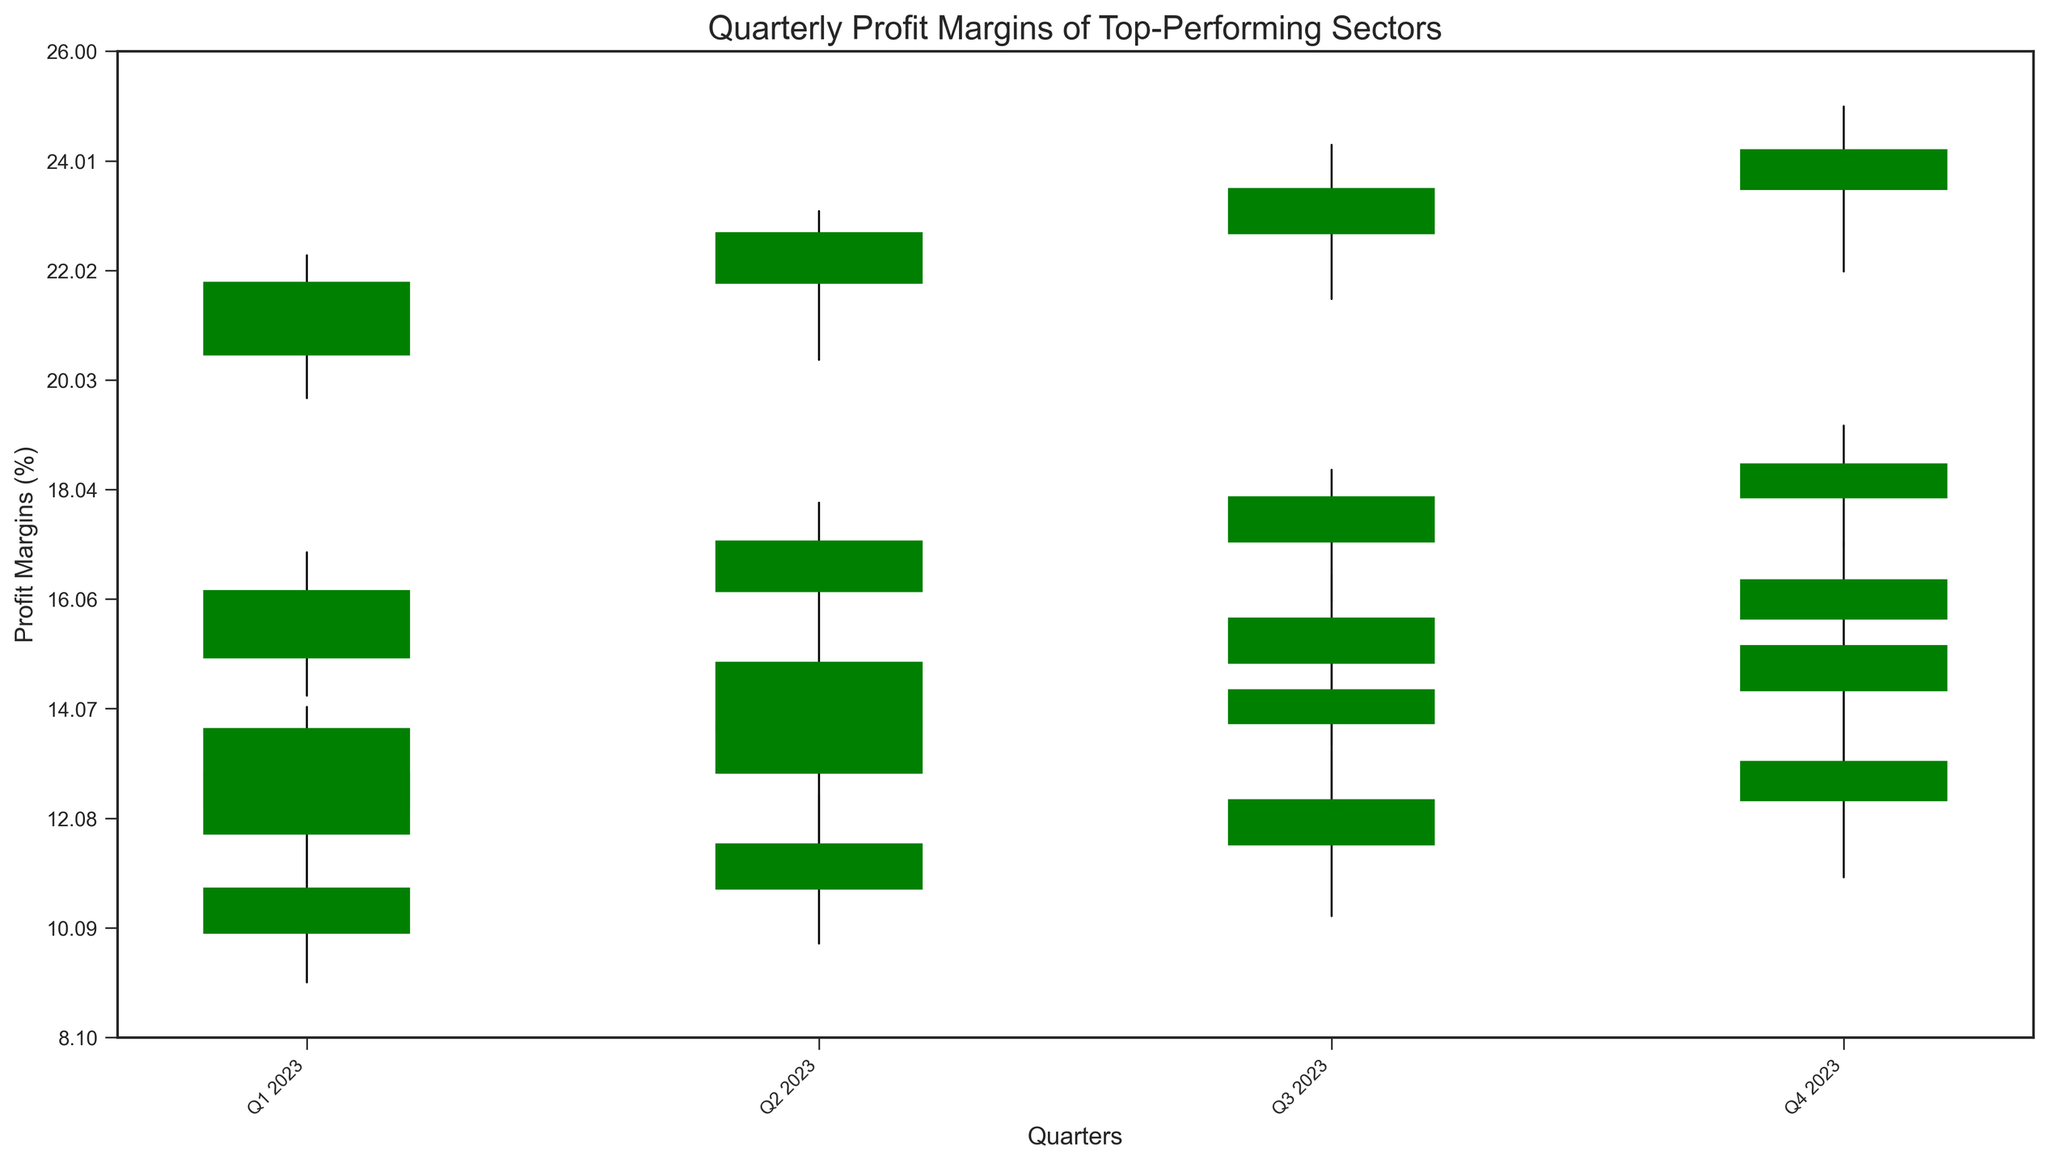Which sector had the highest closing profit margin in Q4 2023? To determine the highest closing profit margin, look at the closing values for Q4 2023. Healthcare has 18.5, Financials has 16.4, Consumer Goods has 15.2, Energy has 13.1, and Technology has 24.2. The highest value is 24.2 for Technology.
Answer: Technology Which sector showed a downward trend in profit margins from Q2 2023 to Q3 2023? Evaluate the opening and closing values from Q2 2023 to Q3 2023 for each sector. Technology (21.8 to 23.5), Healthcare (16.2 to 17.9), Financials (13.7 to 15.7), Consumer Goods (12.9 to 14.4), and Energy (10.8 to 12.4) all show an increase, indicating that no sector had a downward trend during this period.
Answer: None What is the average high profit margin across all sectors in Q3 2023? Sum up the high profit margins for Q3 2023 and divide by the number of sectors (5 sectors). (24.3+18.4+16.5+15.0+13.3) = 87.5. The average is 87.5/5 = 17.5.
Answer: 17.5 Which sector had the most stable profit margins in 2023 (based on the difference between the highest and lowest values)? Determine the range for each sector by subtracting the lowest value from the highest. Technology: (25.0 - 19.7) = 5.3, Healthcare: (19.2 - 14.3) = 4.9, Financials: (17.1 - 11.9) = 5.2, Consumer Goods: (16.0 - 10.9) = 5.1, Energy: (14.2 - 9.1) = 5.1. Healthcare has the smallest range.
Answer: Healthcare Which sector had the lowest opening profit margin in any quarter of 2023? Look at the lowest opening values for each quarter. The lowest values for each sector: Technology (20.5), Healthcare (15.0), Financials (12.3), Consumer Goods (11.8), Energy (10.0). The lowest value is 10.0 in Energy.
Answer: Energy Did all sectors have increasing closing profit margins from Q1 2023 to Q4 2023? Check the closing values from Q1 2023 to Q4 2023 for each sector: Technology (21.8 to 24.2), Healthcare (16.2 to 18.5), Financials (13.7 to 16.4), Consumer Goods (12.9 to 15.2), Energy (10.8 to 13.1). All sectors had increasing closing profit margins.
Answer: Yes Which quarter had the highest overall high profit margin across all sectors? Compare the high values across all quarters. Q1 2023: (22.3+16.9+14.1+13.5+11.7) = 78.5, Q2 2023: (23.1+17.8+15.2+14.3+12.5) = 82.9, Q3 2023: (24.3+18.4+16.5+15.0+13.3) = 87.5, Q4 2023: (25.0+19.2+17.1+16.0+14.2) = 91.5. Q4 2023 had the highest overall high profit margin.
Answer: Q4 2023 